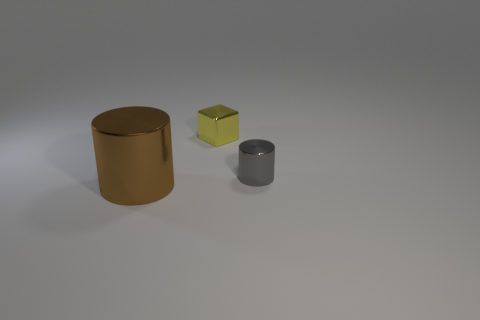Is the size of the metal cylinder behind the big metallic cylinder the same as the shiny cylinder on the left side of the small cube?
Provide a short and direct response. No. How many cylinders are either small shiny things or small cyan matte objects?
Your response must be concise. 1. Is the tiny cube behind the tiny cylinder made of the same material as the large brown thing?
Your answer should be compact. Yes. How many other things are the same size as the gray cylinder?
Your response must be concise. 1. How many large objects are either yellow blocks or brown objects?
Offer a very short reply. 1. Do the tiny cylinder and the big cylinder have the same color?
Ensure brevity in your answer.  No. Are there more small yellow things behind the small yellow block than brown cylinders that are behind the large brown cylinder?
Your answer should be very brief. No. Does the thing that is right of the yellow shiny thing have the same color as the tiny metallic block?
Your answer should be very brief. No. Is there anything else that has the same color as the big thing?
Keep it short and to the point. No. Is the number of brown metallic things that are behind the tiny gray metallic object greater than the number of large brown cylinders?
Provide a succinct answer. No. 